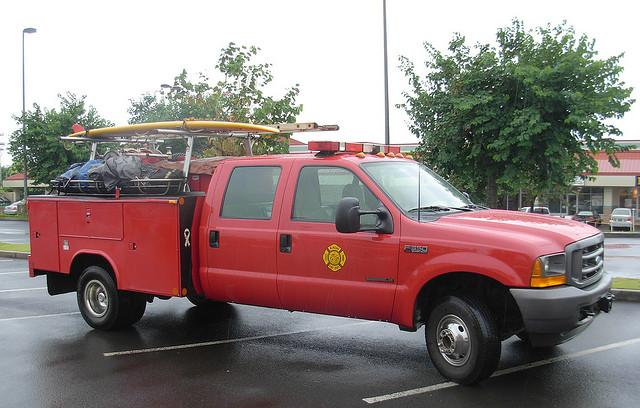What is this vehicle used for? Please explain your reasoning. emergencies. The vehicle has emergency lights on the roof. 